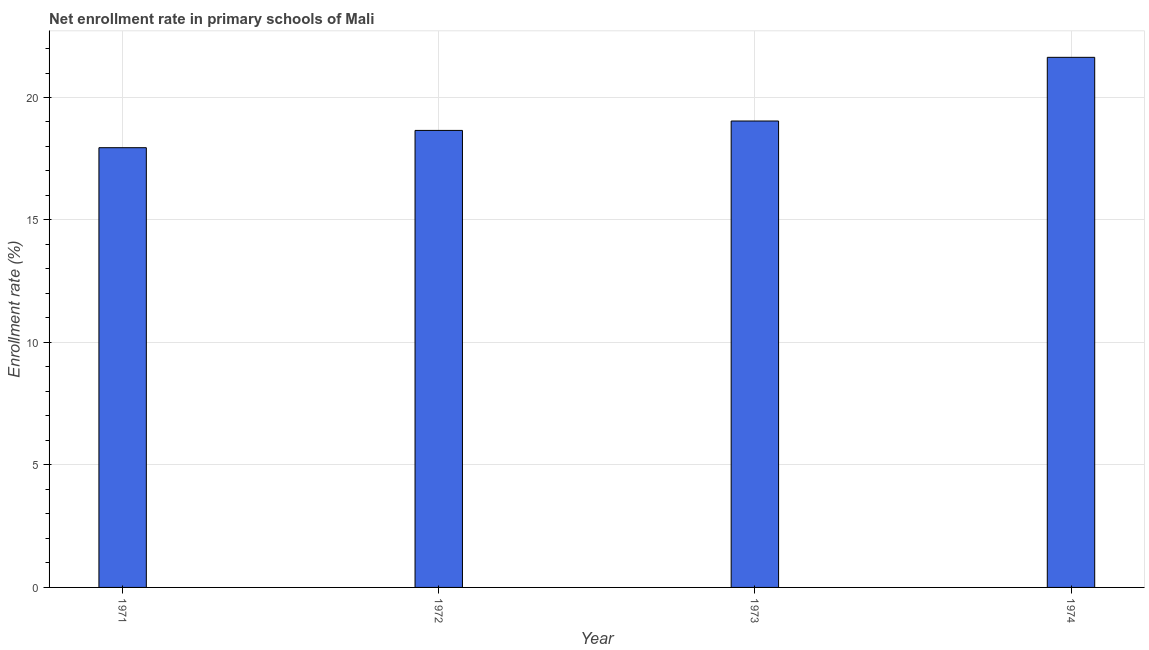Does the graph contain grids?
Your answer should be compact. Yes. What is the title of the graph?
Provide a short and direct response. Net enrollment rate in primary schools of Mali. What is the label or title of the Y-axis?
Keep it short and to the point. Enrollment rate (%). What is the net enrollment rate in primary schools in 1971?
Make the answer very short. 17.95. Across all years, what is the maximum net enrollment rate in primary schools?
Your answer should be compact. 21.64. Across all years, what is the minimum net enrollment rate in primary schools?
Keep it short and to the point. 17.95. In which year was the net enrollment rate in primary schools maximum?
Offer a terse response. 1974. In which year was the net enrollment rate in primary schools minimum?
Provide a short and direct response. 1971. What is the sum of the net enrollment rate in primary schools?
Offer a terse response. 77.29. What is the difference between the net enrollment rate in primary schools in 1972 and 1974?
Offer a very short reply. -2.98. What is the average net enrollment rate in primary schools per year?
Your answer should be compact. 19.32. What is the median net enrollment rate in primary schools?
Make the answer very short. 18.85. What is the ratio of the net enrollment rate in primary schools in 1971 to that in 1974?
Your answer should be compact. 0.83. What is the difference between the highest and the second highest net enrollment rate in primary schools?
Provide a short and direct response. 2.6. What is the difference between the highest and the lowest net enrollment rate in primary schools?
Offer a terse response. 3.69. In how many years, is the net enrollment rate in primary schools greater than the average net enrollment rate in primary schools taken over all years?
Keep it short and to the point. 1. How many bars are there?
Your answer should be very brief. 4. Are all the bars in the graph horizontal?
Make the answer very short. No. Are the values on the major ticks of Y-axis written in scientific E-notation?
Your answer should be compact. No. What is the Enrollment rate (%) in 1971?
Provide a succinct answer. 17.95. What is the Enrollment rate (%) in 1972?
Offer a very short reply. 18.66. What is the Enrollment rate (%) of 1973?
Your answer should be compact. 19.04. What is the Enrollment rate (%) of 1974?
Give a very brief answer. 21.64. What is the difference between the Enrollment rate (%) in 1971 and 1972?
Your answer should be very brief. -0.71. What is the difference between the Enrollment rate (%) in 1971 and 1973?
Provide a short and direct response. -1.09. What is the difference between the Enrollment rate (%) in 1971 and 1974?
Make the answer very short. -3.69. What is the difference between the Enrollment rate (%) in 1972 and 1973?
Keep it short and to the point. -0.38. What is the difference between the Enrollment rate (%) in 1972 and 1974?
Offer a terse response. -2.98. What is the difference between the Enrollment rate (%) in 1973 and 1974?
Offer a terse response. -2.6. What is the ratio of the Enrollment rate (%) in 1971 to that in 1972?
Provide a succinct answer. 0.96. What is the ratio of the Enrollment rate (%) in 1971 to that in 1973?
Make the answer very short. 0.94. What is the ratio of the Enrollment rate (%) in 1971 to that in 1974?
Give a very brief answer. 0.83. What is the ratio of the Enrollment rate (%) in 1972 to that in 1974?
Make the answer very short. 0.86. 